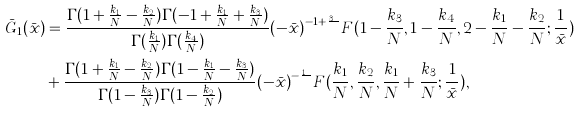<formula> <loc_0><loc_0><loc_500><loc_500>\bar { G } _ { 1 } ( \bar { x } ) & = \frac { \Gamma ( 1 + \frac { k _ { 1 } } { N } - \frac { k _ { 2 } } { N } ) \Gamma ( - 1 + \frac { k _ { 1 } } { N } + \frac { k _ { 3 } } { N } ) } { \Gamma ( \frac { k _ { 1 } } { N } ) \Gamma ( \frac { k _ { 4 } } { N } ) } { ( - \bar { x } ) } ^ { - 1 + \frac { k _ { 3 } } { N } } F ( 1 - \frac { k _ { 3 } } { N } , 1 - \frac { k _ { 4 } } { N } , 2 - \frac { k _ { 1 } } { N } - \frac { k _ { 2 } } { N } ; \frac { 1 } { \bar { x } } ) \\ & + \frac { \Gamma ( 1 + \frac { k _ { 1 } } { N } - \frac { k _ { 2 } } { N } ) \Gamma ( 1 - \frac { k _ { 1 } } { N } - \frac { k _ { 3 } } { N } ) } { \Gamma ( 1 - \frac { k _ { 3 } } { N } ) \Gamma ( 1 - \frac { k _ { 2 } } { N } ) } { ( - \bar { x } ) } ^ { - \frac { k _ { 1 } } { N } } F ( \frac { k _ { 1 } } { N } , \frac { k _ { 2 } } { N } , \frac { k _ { 1 } } { N } + \frac { k _ { 3 } } { N } ; \frac { 1 } { \bar { x } } ) ,</formula> 